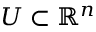Convert formula to latex. <formula><loc_0><loc_0><loc_500><loc_500>U \subset \mathbb { R } ^ { n }</formula> 